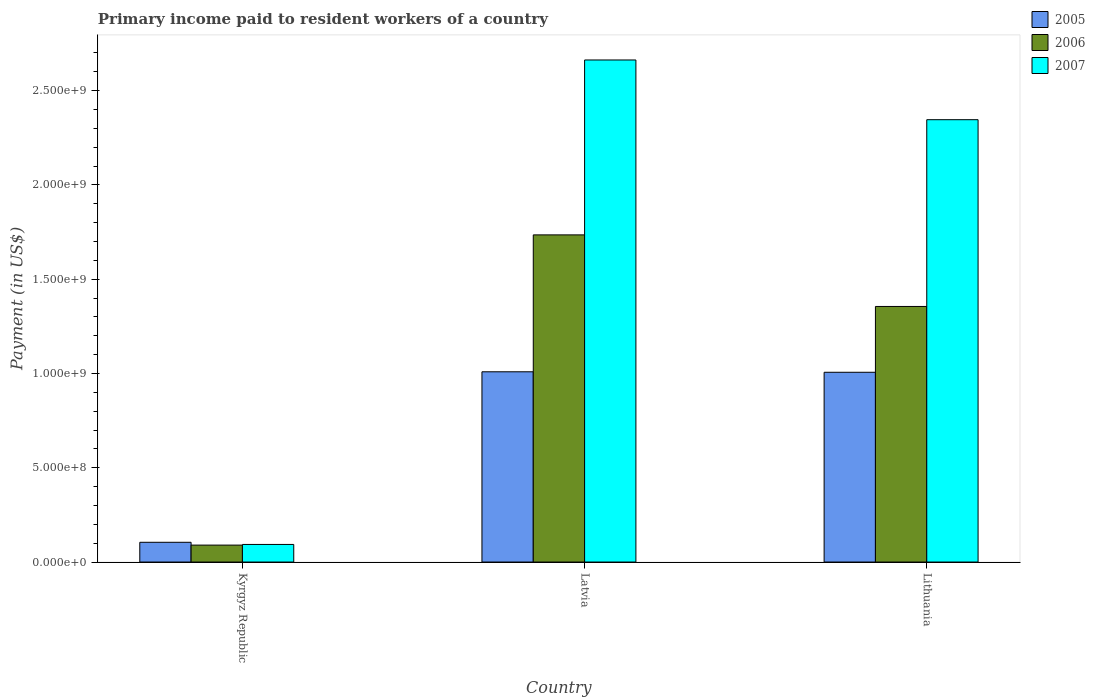How many groups of bars are there?
Ensure brevity in your answer.  3. Are the number of bars per tick equal to the number of legend labels?
Your response must be concise. Yes. How many bars are there on the 1st tick from the right?
Your answer should be compact. 3. What is the label of the 1st group of bars from the left?
Provide a succinct answer. Kyrgyz Republic. What is the amount paid to workers in 2005 in Lithuania?
Make the answer very short. 1.01e+09. Across all countries, what is the maximum amount paid to workers in 2005?
Keep it short and to the point. 1.01e+09. Across all countries, what is the minimum amount paid to workers in 2007?
Your response must be concise. 9.32e+07. In which country was the amount paid to workers in 2006 maximum?
Ensure brevity in your answer.  Latvia. In which country was the amount paid to workers in 2006 minimum?
Offer a very short reply. Kyrgyz Republic. What is the total amount paid to workers in 2007 in the graph?
Your response must be concise. 5.10e+09. What is the difference between the amount paid to workers in 2006 in Latvia and that in Lithuania?
Your answer should be very brief. 3.80e+08. What is the difference between the amount paid to workers in 2006 in Kyrgyz Republic and the amount paid to workers in 2007 in Lithuania?
Ensure brevity in your answer.  -2.26e+09. What is the average amount paid to workers in 2005 per country?
Offer a very short reply. 7.07e+08. What is the difference between the amount paid to workers of/in 2006 and amount paid to workers of/in 2005 in Kyrgyz Republic?
Give a very brief answer. -1.49e+07. In how many countries, is the amount paid to workers in 2006 greater than 2200000000 US$?
Offer a terse response. 0. What is the ratio of the amount paid to workers in 2007 in Kyrgyz Republic to that in Lithuania?
Provide a succinct answer. 0.04. Is the difference between the amount paid to workers in 2006 in Kyrgyz Republic and Latvia greater than the difference between the amount paid to workers in 2005 in Kyrgyz Republic and Latvia?
Offer a very short reply. No. What is the difference between the highest and the second highest amount paid to workers in 2005?
Give a very brief answer. 2.56e+06. What is the difference between the highest and the lowest amount paid to workers in 2005?
Ensure brevity in your answer.  9.04e+08. Is the sum of the amount paid to workers in 2006 in Kyrgyz Republic and Latvia greater than the maximum amount paid to workers in 2005 across all countries?
Your answer should be compact. Yes. Is it the case that in every country, the sum of the amount paid to workers in 2006 and amount paid to workers in 2005 is greater than the amount paid to workers in 2007?
Your answer should be compact. Yes. How many countries are there in the graph?
Offer a very short reply. 3. Does the graph contain any zero values?
Your answer should be compact. No. Where does the legend appear in the graph?
Your response must be concise. Top right. How are the legend labels stacked?
Give a very brief answer. Vertical. What is the title of the graph?
Ensure brevity in your answer.  Primary income paid to resident workers of a country. What is the label or title of the Y-axis?
Provide a short and direct response. Payment (in US$). What is the Payment (in US$) in 2005 in Kyrgyz Republic?
Your answer should be compact. 1.05e+08. What is the Payment (in US$) in 2006 in Kyrgyz Republic?
Your answer should be compact. 8.98e+07. What is the Payment (in US$) of 2007 in Kyrgyz Republic?
Offer a terse response. 9.32e+07. What is the Payment (in US$) in 2005 in Latvia?
Offer a terse response. 1.01e+09. What is the Payment (in US$) of 2006 in Latvia?
Ensure brevity in your answer.  1.74e+09. What is the Payment (in US$) in 2007 in Latvia?
Keep it short and to the point. 2.66e+09. What is the Payment (in US$) of 2005 in Lithuania?
Ensure brevity in your answer.  1.01e+09. What is the Payment (in US$) in 2006 in Lithuania?
Your response must be concise. 1.36e+09. What is the Payment (in US$) of 2007 in Lithuania?
Make the answer very short. 2.35e+09. Across all countries, what is the maximum Payment (in US$) of 2005?
Make the answer very short. 1.01e+09. Across all countries, what is the maximum Payment (in US$) of 2006?
Keep it short and to the point. 1.74e+09. Across all countries, what is the maximum Payment (in US$) of 2007?
Your answer should be compact. 2.66e+09. Across all countries, what is the minimum Payment (in US$) of 2005?
Provide a short and direct response. 1.05e+08. Across all countries, what is the minimum Payment (in US$) in 2006?
Provide a succinct answer. 8.98e+07. Across all countries, what is the minimum Payment (in US$) in 2007?
Your answer should be compact. 9.32e+07. What is the total Payment (in US$) in 2005 in the graph?
Make the answer very short. 2.12e+09. What is the total Payment (in US$) of 2006 in the graph?
Your answer should be compact. 3.18e+09. What is the total Payment (in US$) of 2007 in the graph?
Keep it short and to the point. 5.10e+09. What is the difference between the Payment (in US$) of 2005 in Kyrgyz Republic and that in Latvia?
Give a very brief answer. -9.04e+08. What is the difference between the Payment (in US$) in 2006 in Kyrgyz Republic and that in Latvia?
Ensure brevity in your answer.  -1.65e+09. What is the difference between the Payment (in US$) in 2007 in Kyrgyz Republic and that in Latvia?
Keep it short and to the point. -2.57e+09. What is the difference between the Payment (in US$) in 2005 in Kyrgyz Republic and that in Lithuania?
Your answer should be very brief. -9.02e+08. What is the difference between the Payment (in US$) of 2006 in Kyrgyz Republic and that in Lithuania?
Ensure brevity in your answer.  -1.27e+09. What is the difference between the Payment (in US$) in 2007 in Kyrgyz Republic and that in Lithuania?
Provide a succinct answer. -2.25e+09. What is the difference between the Payment (in US$) in 2005 in Latvia and that in Lithuania?
Provide a short and direct response. 2.56e+06. What is the difference between the Payment (in US$) in 2006 in Latvia and that in Lithuania?
Provide a succinct answer. 3.80e+08. What is the difference between the Payment (in US$) in 2007 in Latvia and that in Lithuania?
Your answer should be very brief. 3.17e+08. What is the difference between the Payment (in US$) in 2005 in Kyrgyz Republic and the Payment (in US$) in 2006 in Latvia?
Ensure brevity in your answer.  -1.63e+09. What is the difference between the Payment (in US$) of 2005 in Kyrgyz Republic and the Payment (in US$) of 2007 in Latvia?
Your response must be concise. -2.56e+09. What is the difference between the Payment (in US$) in 2006 in Kyrgyz Republic and the Payment (in US$) in 2007 in Latvia?
Provide a succinct answer. -2.57e+09. What is the difference between the Payment (in US$) in 2005 in Kyrgyz Republic and the Payment (in US$) in 2006 in Lithuania?
Offer a very short reply. -1.25e+09. What is the difference between the Payment (in US$) of 2005 in Kyrgyz Republic and the Payment (in US$) of 2007 in Lithuania?
Your answer should be very brief. -2.24e+09. What is the difference between the Payment (in US$) in 2006 in Kyrgyz Republic and the Payment (in US$) in 2007 in Lithuania?
Give a very brief answer. -2.26e+09. What is the difference between the Payment (in US$) of 2005 in Latvia and the Payment (in US$) of 2006 in Lithuania?
Offer a very short reply. -3.46e+08. What is the difference between the Payment (in US$) in 2005 in Latvia and the Payment (in US$) in 2007 in Lithuania?
Offer a terse response. -1.34e+09. What is the difference between the Payment (in US$) in 2006 in Latvia and the Payment (in US$) in 2007 in Lithuania?
Ensure brevity in your answer.  -6.11e+08. What is the average Payment (in US$) of 2005 per country?
Provide a short and direct response. 7.07e+08. What is the average Payment (in US$) of 2006 per country?
Your answer should be compact. 1.06e+09. What is the average Payment (in US$) of 2007 per country?
Offer a very short reply. 1.70e+09. What is the difference between the Payment (in US$) in 2005 and Payment (in US$) in 2006 in Kyrgyz Republic?
Provide a short and direct response. 1.49e+07. What is the difference between the Payment (in US$) of 2005 and Payment (in US$) of 2007 in Kyrgyz Republic?
Offer a terse response. 1.15e+07. What is the difference between the Payment (in US$) in 2006 and Payment (in US$) in 2007 in Kyrgyz Republic?
Keep it short and to the point. -3.41e+06. What is the difference between the Payment (in US$) of 2005 and Payment (in US$) of 2006 in Latvia?
Ensure brevity in your answer.  -7.26e+08. What is the difference between the Payment (in US$) of 2005 and Payment (in US$) of 2007 in Latvia?
Your answer should be very brief. -1.65e+09. What is the difference between the Payment (in US$) of 2006 and Payment (in US$) of 2007 in Latvia?
Ensure brevity in your answer.  -9.28e+08. What is the difference between the Payment (in US$) of 2005 and Payment (in US$) of 2006 in Lithuania?
Provide a short and direct response. -3.49e+08. What is the difference between the Payment (in US$) in 2005 and Payment (in US$) in 2007 in Lithuania?
Offer a terse response. -1.34e+09. What is the difference between the Payment (in US$) of 2006 and Payment (in US$) of 2007 in Lithuania?
Provide a succinct answer. -9.91e+08. What is the ratio of the Payment (in US$) in 2005 in Kyrgyz Republic to that in Latvia?
Your answer should be compact. 0.1. What is the ratio of the Payment (in US$) of 2006 in Kyrgyz Republic to that in Latvia?
Provide a succinct answer. 0.05. What is the ratio of the Payment (in US$) of 2007 in Kyrgyz Republic to that in Latvia?
Ensure brevity in your answer.  0.04. What is the ratio of the Payment (in US$) in 2005 in Kyrgyz Republic to that in Lithuania?
Keep it short and to the point. 0.1. What is the ratio of the Payment (in US$) of 2006 in Kyrgyz Republic to that in Lithuania?
Your response must be concise. 0.07. What is the ratio of the Payment (in US$) in 2007 in Kyrgyz Republic to that in Lithuania?
Offer a very short reply. 0.04. What is the ratio of the Payment (in US$) in 2006 in Latvia to that in Lithuania?
Provide a short and direct response. 1.28. What is the ratio of the Payment (in US$) in 2007 in Latvia to that in Lithuania?
Give a very brief answer. 1.14. What is the difference between the highest and the second highest Payment (in US$) of 2005?
Offer a terse response. 2.56e+06. What is the difference between the highest and the second highest Payment (in US$) of 2006?
Provide a short and direct response. 3.80e+08. What is the difference between the highest and the second highest Payment (in US$) of 2007?
Ensure brevity in your answer.  3.17e+08. What is the difference between the highest and the lowest Payment (in US$) of 2005?
Give a very brief answer. 9.04e+08. What is the difference between the highest and the lowest Payment (in US$) in 2006?
Your response must be concise. 1.65e+09. What is the difference between the highest and the lowest Payment (in US$) in 2007?
Ensure brevity in your answer.  2.57e+09. 